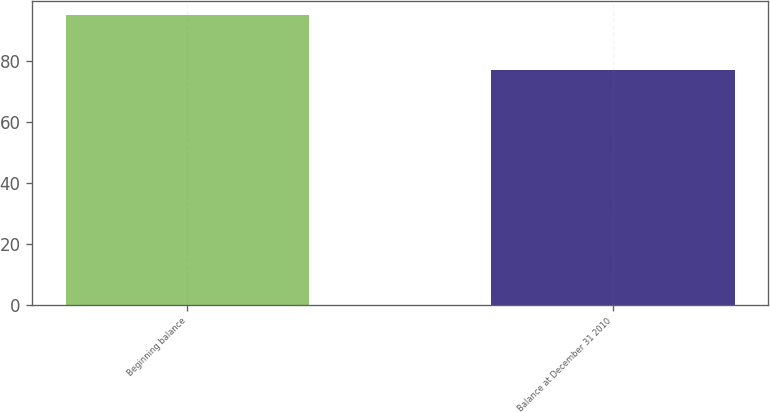<chart> <loc_0><loc_0><loc_500><loc_500><bar_chart><fcel>Beginning balance<fcel>Balance at December 31 2010<nl><fcel>95<fcel>77<nl></chart> 